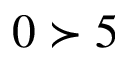Convert formula to latex. <formula><loc_0><loc_0><loc_500><loc_500>0 \succ 5</formula> 